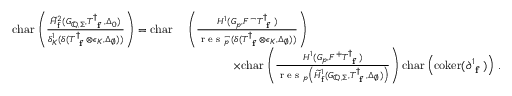<formula> <loc_0><loc_0><loc_500><loc_500>\begin{array} { r } { \begin{array} { r l } { c h a r \left ( \frac { \widetilde { H } _ { f } ^ { 2 } ( G _ { \mathbb { Q } , \Sigma } , T _ { f } ^ { \dagger } , \Delta _ { 0 } ) } { \delta _ { K } ^ { 1 } ( \delta ( T _ { f } ^ { \dagger } \otimes \epsilon _ { K } , \Delta _ { \emptyset } ) ) } \right ) = c h a r } & { \, \left ( \frac { H ^ { 1 } ( G _ { p } , F ^ { - } T _ { f } ^ { \dagger } ) } { r e s _ { p } ^ { - } ( \delta ( T _ { f } ^ { \dagger } \otimes \epsilon _ { K } , \Delta _ { \emptyset } ) ) } \right ) } \\ & { \quad \times c h a r \left ( \frac { H ^ { 1 } ( G _ { p } , F ^ { + } T _ { f } ^ { \dagger } ) } { r e s _ { p } \left ( \widetilde { H } _ { f } ^ { 1 } ( G _ { \mathbb { Q } , \Sigma } , T _ { f } ^ { \dagger } , \Delta _ { \emptyset } ) \right ) } \right ) c h a r \left ( c o k e r ( \partial _ { f } ^ { 1 } ) \right ) \, . } \end{array} } \end{array}</formula> 